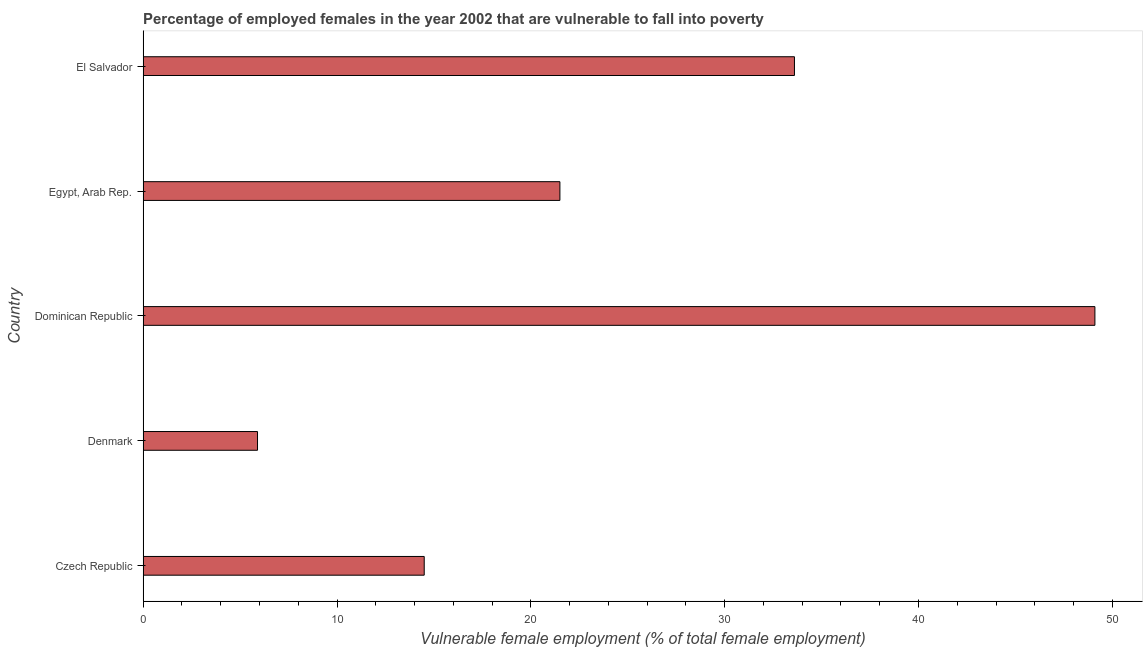Does the graph contain grids?
Keep it short and to the point. No. What is the title of the graph?
Your answer should be very brief. Percentage of employed females in the year 2002 that are vulnerable to fall into poverty. What is the label or title of the X-axis?
Ensure brevity in your answer.  Vulnerable female employment (% of total female employment). What is the label or title of the Y-axis?
Ensure brevity in your answer.  Country. Across all countries, what is the maximum percentage of employed females who are vulnerable to fall into poverty?
Your answer should be very brief. 49.1. Across all countries, what is the minimum percentage of employed females who are vulnerable to fall into poverty?
Give a very brief answer. 5.9. In which country was the percentage of employed females who are vulnerable to fall into poverty maximum?
Your answer should be compact. Dominican Republic. In which country was the percentage of employed females who are vulnerable to fall into poverty minimum?
Offer a terse response. Denmark. What is the sum of the percentage of employed females who are vulnerable to fall into poverty?
Provide a short and direct response. 124.6. What is the difference between the percentage of employed females who are vulnerable to fall into poverty in Czech Republic and El Salvador?
Give a very brief answer. -19.1. What is the average percentage of employed females who are vulnerable to fall into poverty per country?
Your answer should be very brief. 24.92. What is the median percentage of employed females who are vulnerable to fall into poverty?
Provide a succinct answer. 21.5. In how many countries, is the percentage of employed females who are vulnerable to fall into poverty greater than 14 %?
Offer a terse response. 4. What is the ratio of the percentage of employed females who are vulnerable to fall into poverty in Denmark to that in El Salvador?
Make the answer very short. 0.18. Is the difference between the percentage of employed females who are vulnerable to fall into poverty in Czech Republic and Denmark greater than the difference between any two countries?
Provide a short and direct response. No. What is the difference between the highest and the lowest percentage of employed females who are vulnerable to fall into poverty?
Ensure brevity in your answer.  43.2. Are all the bars in the graph horizontal?
Ensure brevity in your answer.  Yes. What is the difference between two consecutive major ticks on the X-axis?
Offer a very short reply. 10. Are the values on the major ticks of X-axis written in scientific E-notation?
Ensure brevity in your answer.  No. What is the Vulnerable female employment (% of total female employment) in Denmark?
Ensure brevity in your answer.  5.9. What is the Vulnerable female employment (% of total female employment) of Dominican Republic?
Give a very brief answer. 49.1. What is the Vulnerable female employment (% of total female employment) in Egypt, Arab Rep.?
Give a very brief answer. 21.5. What is the Vulnerable female employment (% of total female employment) in El Salvador?
Offer a very short reply. 33.6. What is the difference between the Vulnerable female employment (% of total female employment) in Czech Republic and Denmark?
Give a very brief answer. 8.6. What is the difference between the Vulnerable female employment (% of total female employment) in Czech Republic and Dominican Republic?
Provide a succinct answer. -34.6. What is the difference between the Vulnerable female employment (% of total female employment) in Czech Republic and El Salvador?
Make the answer very short. -19.1. What is the difference between the Vulnerable female employment (% of total female employment) in Denmark and Dominican Republic?
Keep it short and to the point. -43.2. What is the difference between the Vulnerable female employment (% of total female employment) in Denmark and Egypt, Arab Rep.?
Offer a terse response. -15.6. What is the difference between the Vulnerable female employment (% of total female employment) in Denmark and El Salvador?
Provide a succinct answer. -27.7. What is the difference between the Vulnerable female employment (% of total female employment) in Dominican Republic and Egypt, Arab Rep.?
Your answer should be compact. 27.6. What is the difference between the Vulnerable female employment (% of total female employment) in Dominican Republic and El Salvador?
Your answer should be very brief. 15.5. What is the ratio of the Vulnerable female employment (% of total female employment) in Czech Republic to that in Denmark?
Offer a terse response. 2.46. What is the ratio of the Vulnerable female employment (% of total female employment) in Czech Republic to that in Dominican Republic?
Give a very brief answer. 0.29. What is the ratio of the Vulnerable female employment (% of total female employment) in Czech Republic to that in Egypt, Arab Rep.?
Offer a terse response. 0.67. What is the ratio of the Vulnerable female employment (% of total female employment) in Czech Republic to that in El Salvador?
Provide a succinct answer. 0.43. What is the ratio of the Vulnerable female employment (% of total female employment) in Denmark to that in Dominican Republic?
Your answer should be very brief. 0.12. What is the ratio of the Vulnerable female employment (% of total female employment) in Denmark to that in Egypt, Arab Rep.?
Give a very brief answer. 0.27. What is the ratio of the Vulnerable female employment (% of total female employment) in Denmark to that in El Salvador?
Your response must be concise. 0.18. What is the ratio of the Vulnerable female employment (% of total female employment) in Dominican Republic to that in Egypt, Arab Rep.?
Your response must be concise. 2.28. What is the ratio of the Vulnerable female employment (% of total female employment) in Dominican Republic to that in El Salvador?
Offer a very short reply. 1.46. What is the ratio of the Vulnerable female employment (% of total female employment) in Egypt, Arab Rep. to that in El Salvador?
Provide a short and direct response. 0.64. 